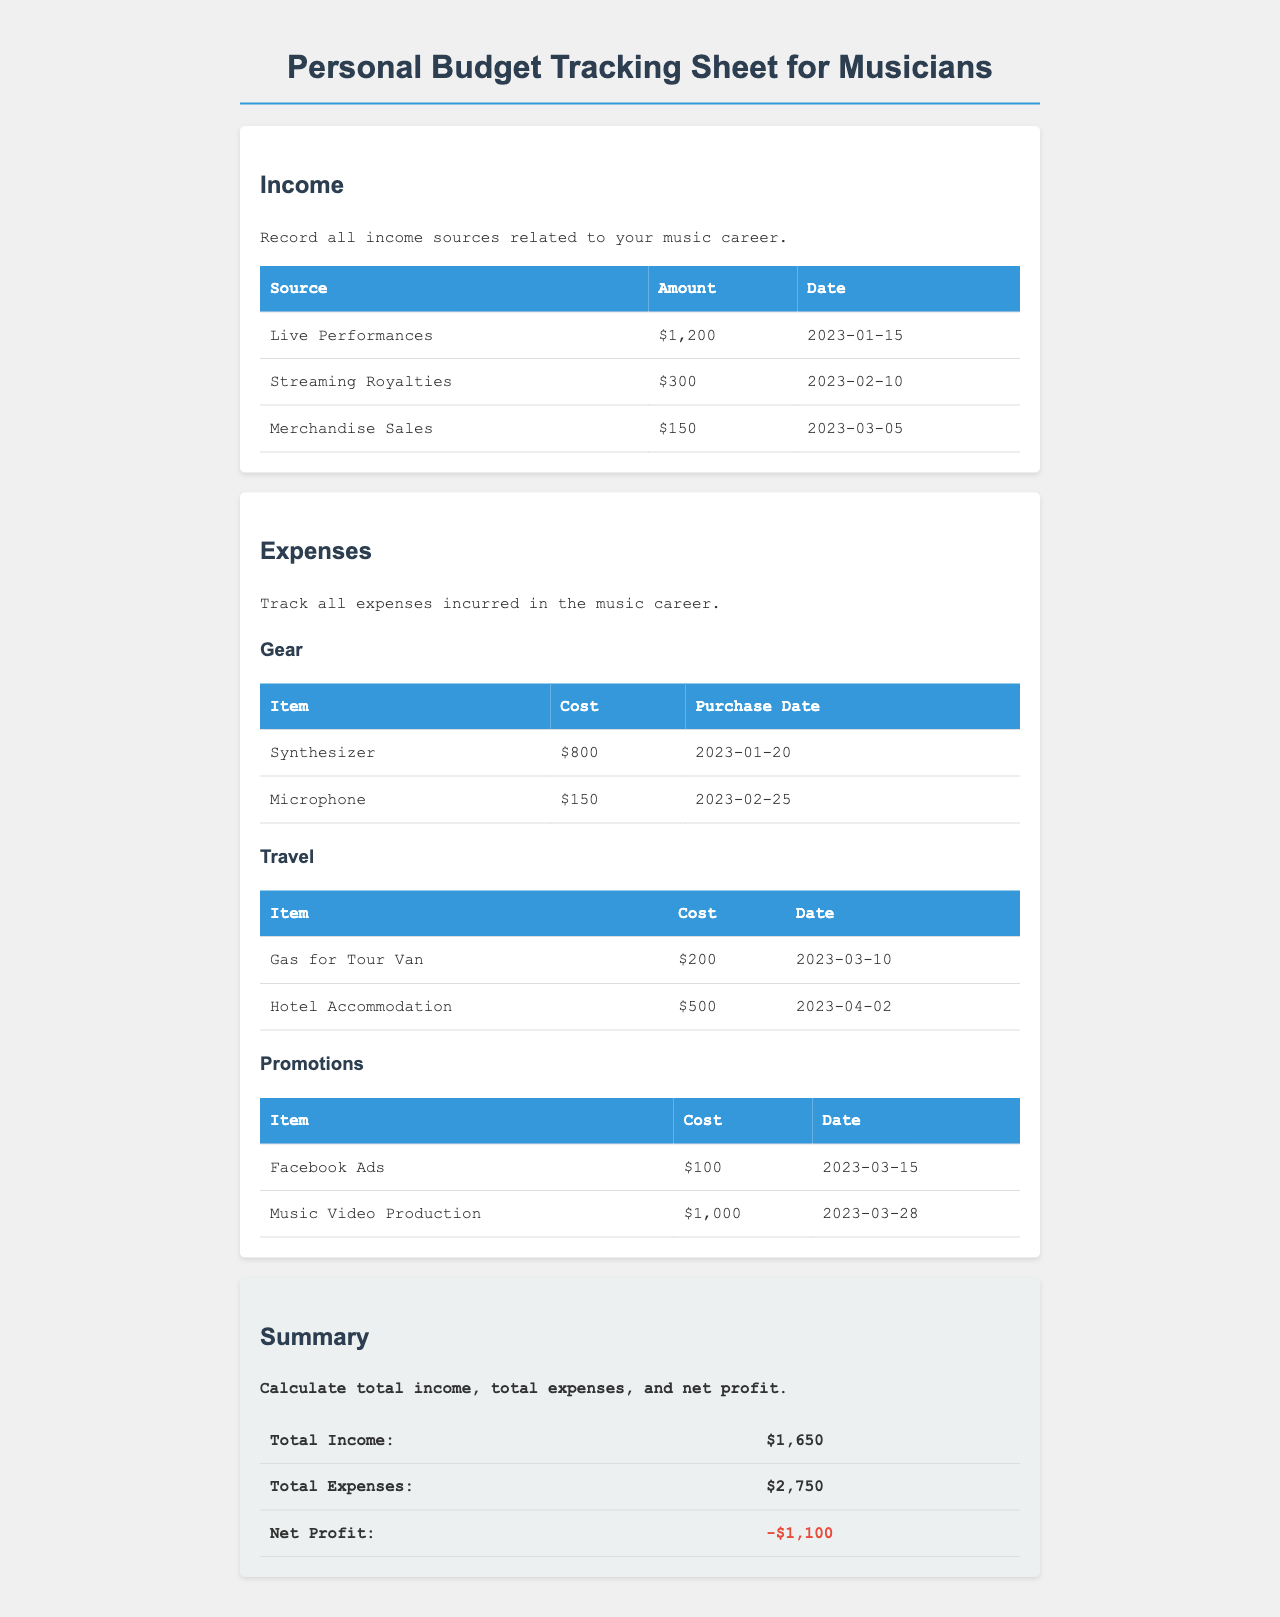What is the total income? The total income is the sum of all income sources listed in the document: $1,200 + $300 + $150 = $1,650.
Answer: $1,650 How much did the microphone cost? The document states the cost of the microphone under the gear expenses section, which is $150.
Answer: $150 When was the hotel accommodation expense made? The date for the hotel accommodation expense is listed in the travel expenses section, which is 2023-04-02.
Answer: 2023-04-02 What is the total cost of gear? The total cost of gear is calculated by adding the individual costs of the synthesizer and microphone: $800 + $150 = $950.
Answer: $950 How much was spent on Facebook ads? The document indicates the cost of Facebook ads under promotions, which is $100.
Answer: $100 What is the net profit reported? The net profit is the difference between total income and total expenses; the document states it is -$1,100.
Answer: -$1,100 What date is associated with merchandise sales? The date for merchandise sales is provided in the income section, which is 2023-03-05.
Answer: 2023-03-05 What was the total expense on promotions? The total expense on promotions is calculated by adding the costs of Facebook ads and music video production: $100 + $1,000 = $1,100.
Answer: $1,100 Which item had the highest cost in the gear section? The document indicates that the synthesizer costs $800, making it the highest cost item under gear.
Answer: Synthesizer 